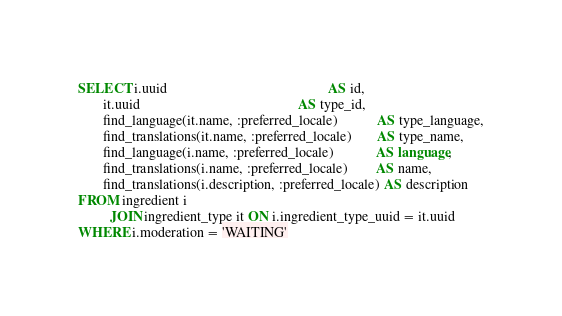Convert code to text. <code><loc_0><loc_0><loc_500><loc_500><_SQL_>SELECT i.uuid                                              AS id,
       it.uuid                                             AS type_id,
       find_language(it.name, :preferred_locale)           AS type_language,
       find_translations(it.name, :preferred_locale)       AS type_name,
       find_language(i.name, :preferred_locale)            AS language,
       find_translations(i.name, :preferred_locale)        AS name,
       find_translations(i.description, :preferred_locale) AS description
FROM ingredient i
         JOIN ingredient_type it ON i.ingredient_type_uuid = it.uuid
WHERE i.moderation = 'WAITING'
</code> 